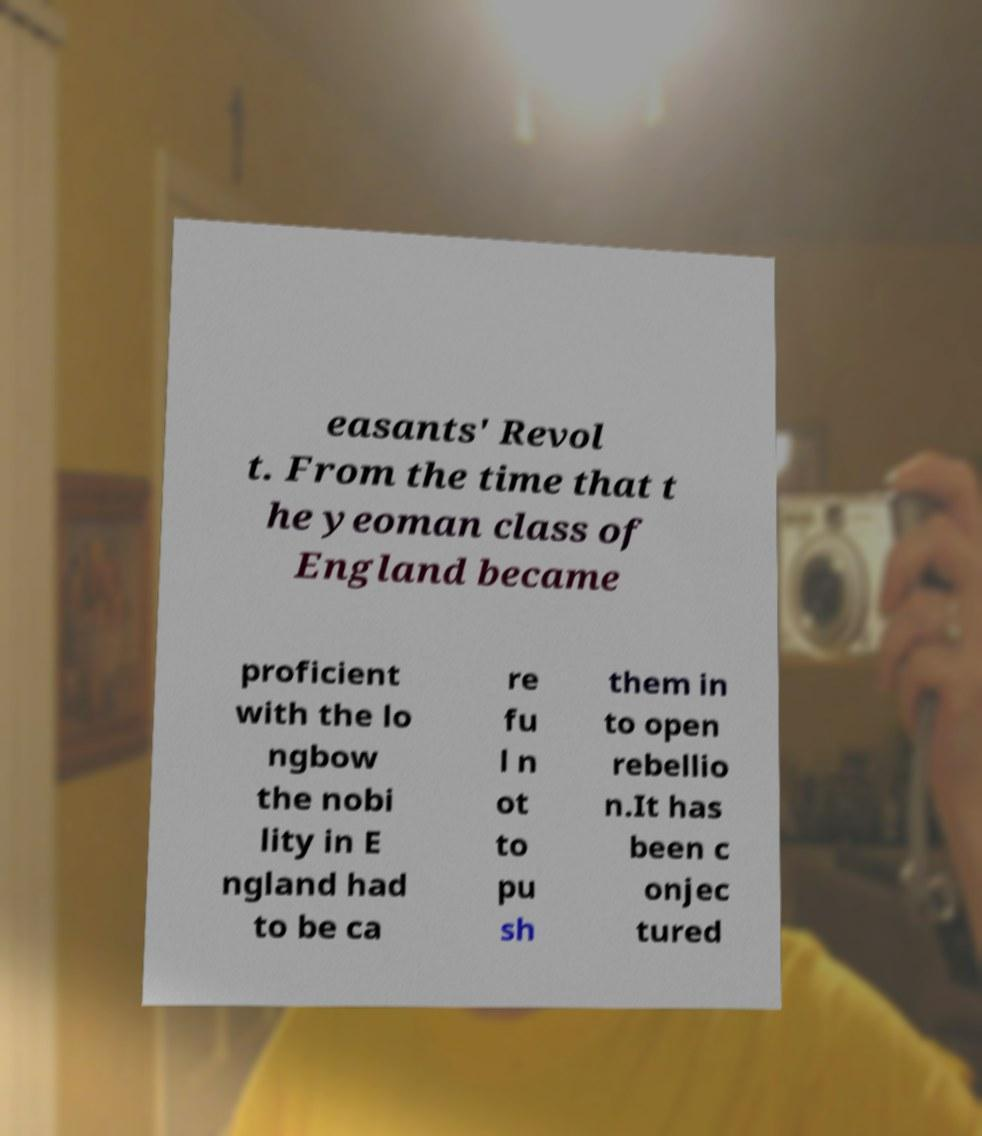For documentation purposes, I need the text within this image transcribed. Could you provide that? easants' Revol t. From the time that t he yeoman class of England became proficient with the lo ngbow the nobi lity in E ngland had to be ca re fu l n ot to pu sh them in to open rebellio n.It has been c onjec tured 